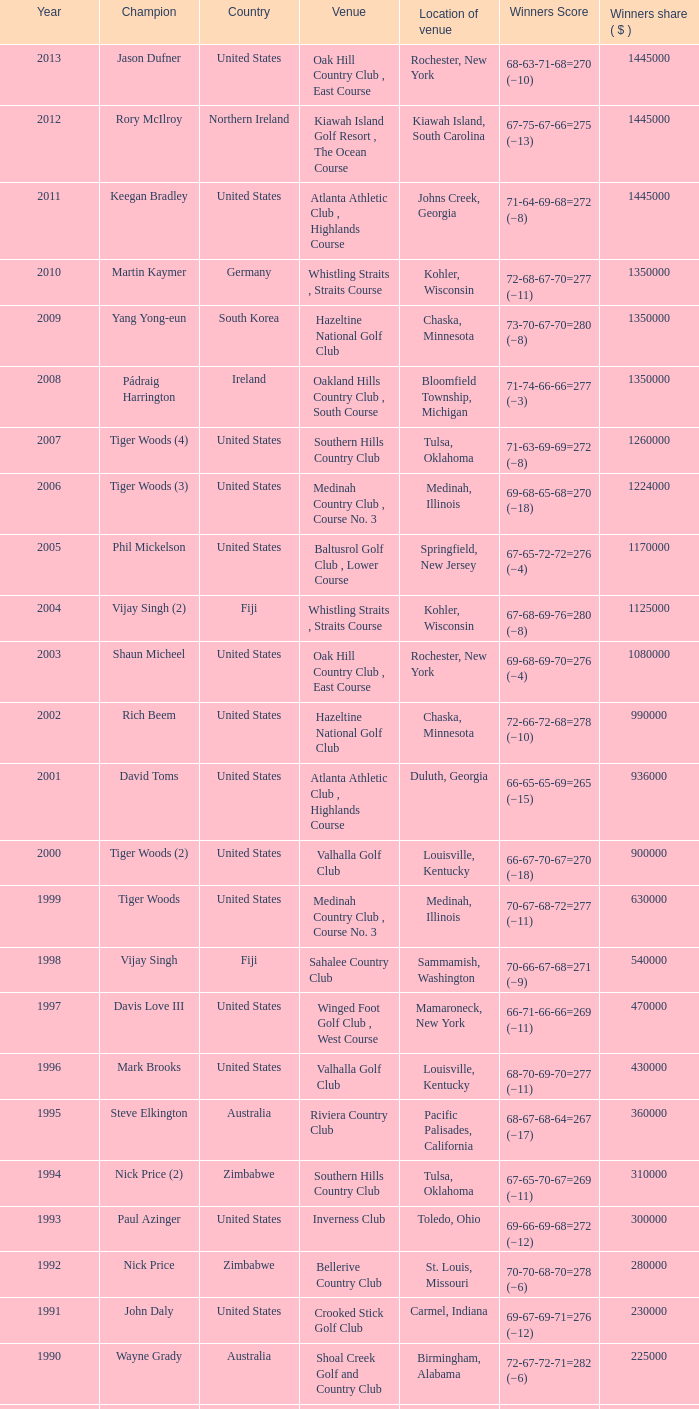Where is the bellerive country club site situated? St. Louis, Missouri. 